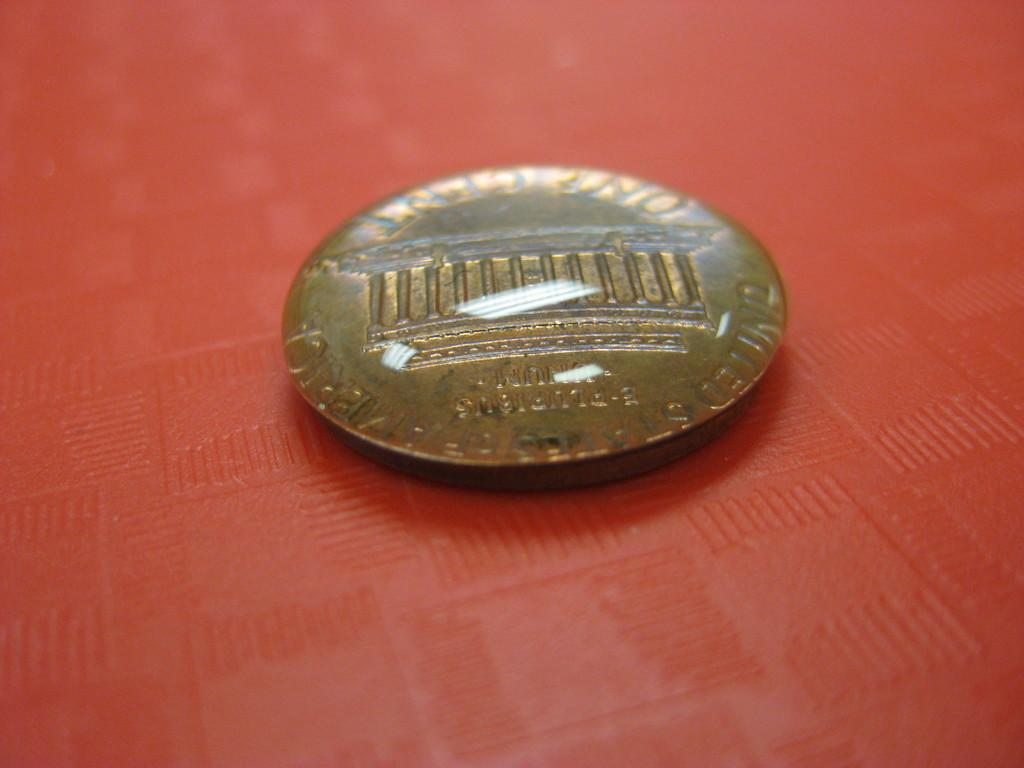Provide a one-sentence caption for the provided image. A one cent coin from the United States of America is laying face down. 